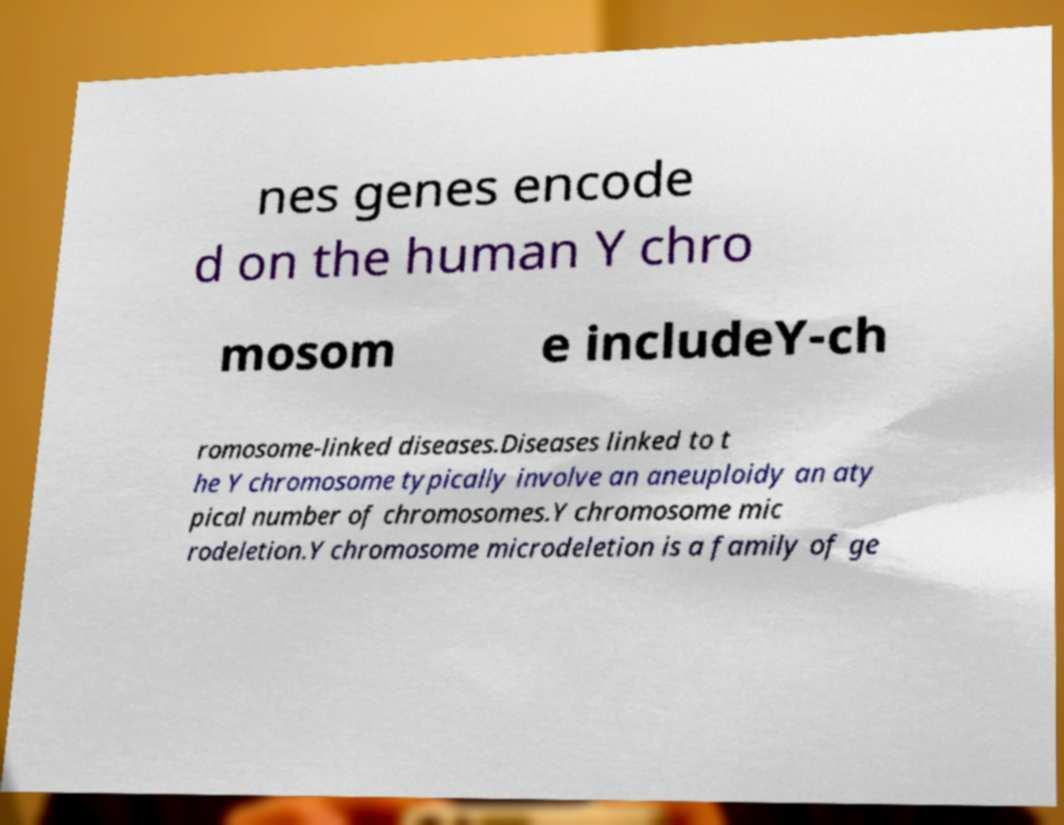There's text embedded in this image that I need extracted. Can you transcribe it verbatim? nes genes encode d on the human Y chro mosom e includeY-ch romosome-linked diseases.Diseases linked to t he Y chromosome typically involve an aneuploidy an aty pical number of chromosomes.Y chromosome mic rodeletion.Y chromosome microdeletion is a family of ge 